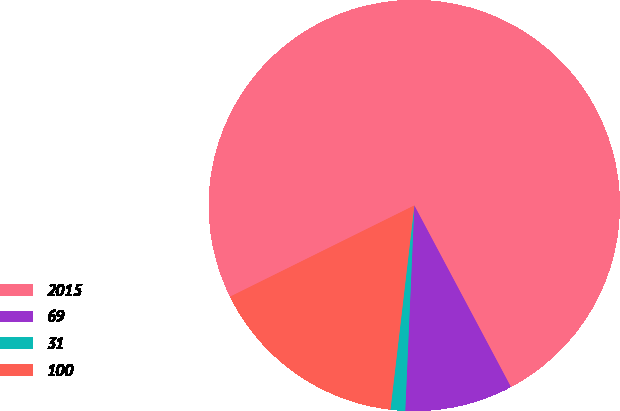Convert chart to OTSL. <chart><loc_0><loc_0><loc_500><loc_500><pie_chart><fcel>2015<fcel>69<fcel>31<fcel>100<nl><fcel>74.54%<fcel>8.49%<fcel>1.15%<fcel>15.83%<nl></chart> 